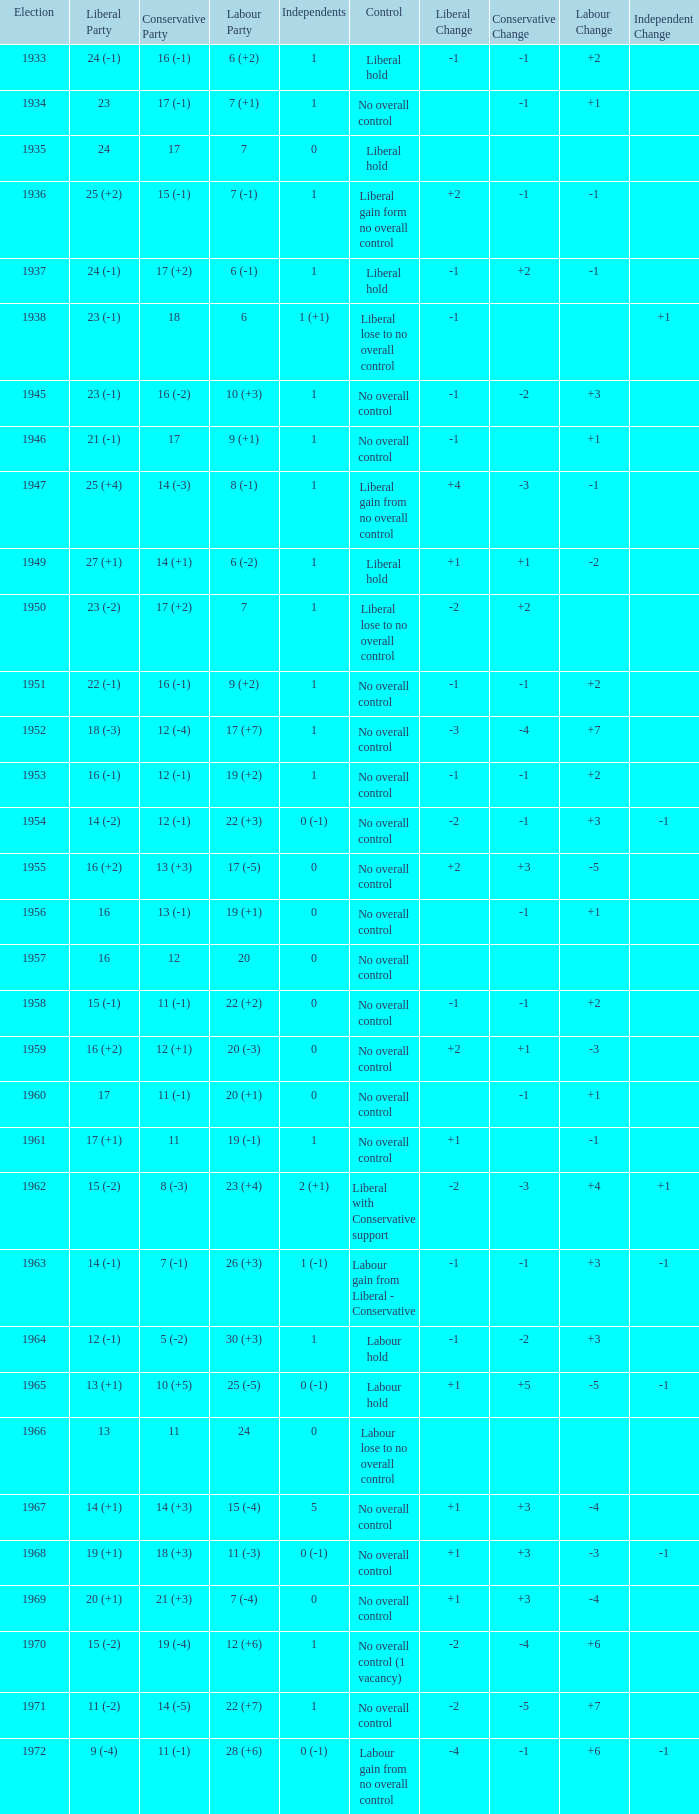What was the Liberal Party result from the election having a Conservative Party result of 16 (-1) and Labour of 6 (+2)? 24 (-1). 